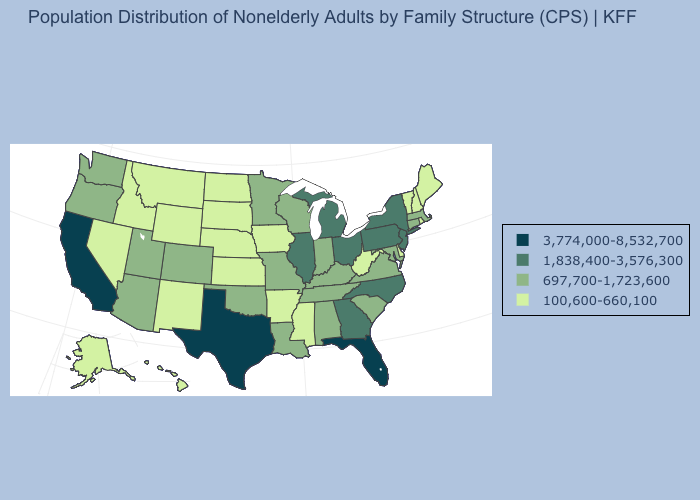Does Florida have the highest value in the South?
Give a very brief answer. Yes. Which states hav the highest value in the MidWest?
Give a very brief answer. Illinois, Michigan, Ohio. Name the states that have a value in the range 3,774,000-8,532,700?
Answer briefly. California, Florida, Texas. What is the highest value in the Northeast ?
Give a very brief answer. 1,838,400-3,576,300. What is the value of Arkansas?
Write a very short answer. 100,600-660,100. Which states have the lowest value in the USA?
Answer briefly. Alaska, Arkansas, Delaware, Hawaii, Idaho, Iowa, Kansas, Maine, Mississippi, Montana, Nebraska, Nevada, New Hampshire, New Mexico, North Dakota, Rhode Island, South Dakota, Vermont, West Virginia, Wyoming. What is the highest value in the MidWest ?
Be succinct. 1,838,400-3,576,300. Does Delaware have a lower value than Michigan?
Answer briefly. Yes. What is the value of Connecticut?
Give a very brief answer. 697,700-1,723,600. Name the states that have a value in the range 3,774,000-8,532,700?
Answer briefly. California, Florida, Texas. Does Alabama have a lower value than North Carolina?
Quick response, please. Yes. What is the value of Kentucky?
Concise answer only. 697,700-1,723,600. What is the highest value in the USA?
Answer briefly. 3,774,000-8,532,700. Among the states that border New Hampshire , which have the lowest value?
Give a very brief answer. Maine, Vermont. What is the value of Oregon?
Write a very short answer. 697,700-1,723,600. 